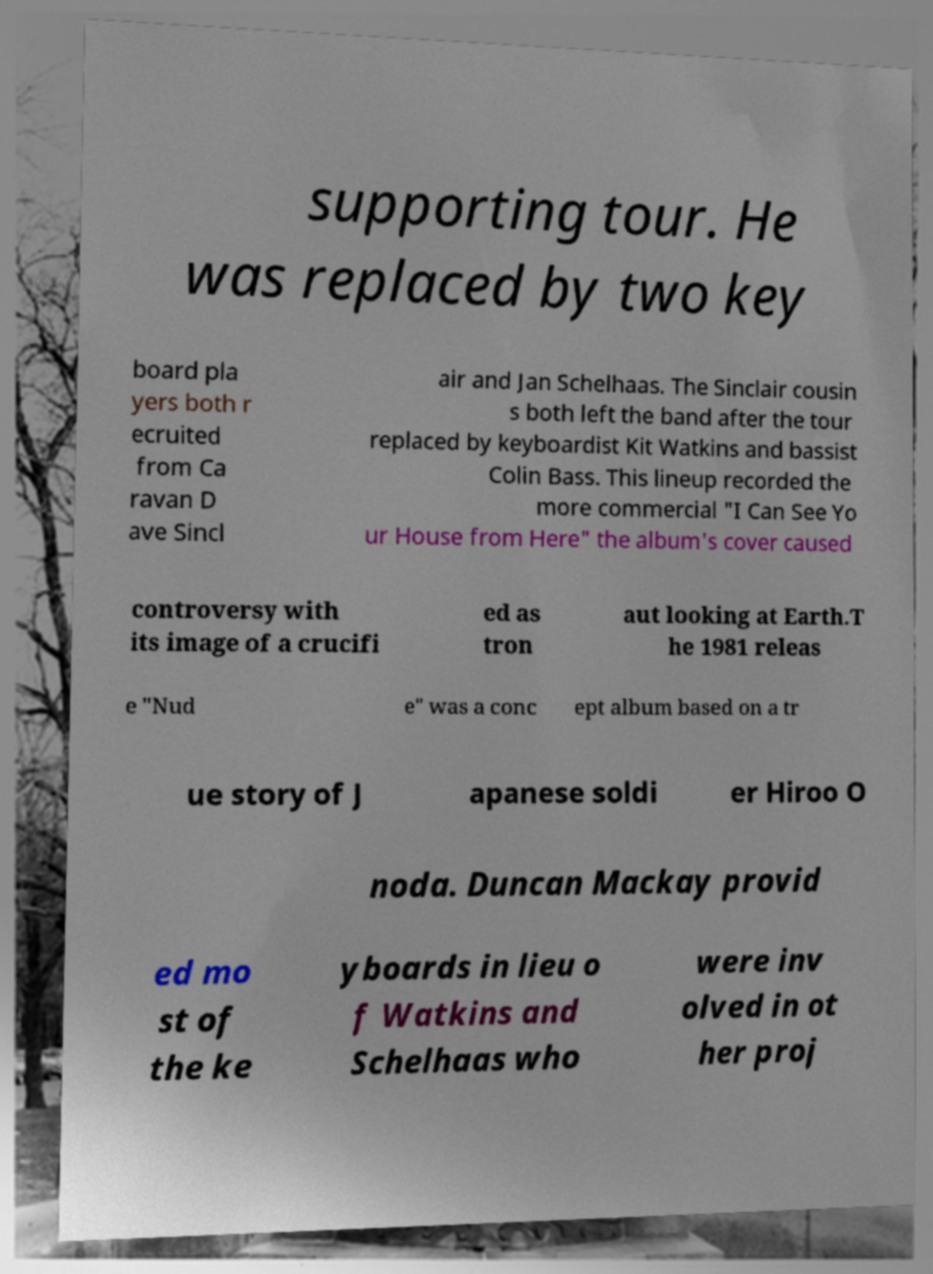What messages or text are displayed in this image? I need them in a readable, typed format. supporting tour. He was replaced by two key board pla yers both r ecruited from Ca ravan D ave Sincl air and Jan Schelhaas. The Sinclair cousin s both left the band after the tour replaced by keyboardist Kit Watkins and bassist Colin Bass. This lineup recorded the more commercial "I Can See Yo ur House from Here" the album's cover caused controversy with its image of a crucifi ed as tron aut looking at Earth.T he 1981 releas e "Nud e" was a conc ept album based on a tr ue story of J apanese soldi er Hiroo O noda. Duncan Mackay provid ed mo st of the ke yboards in lieu o f Watkins and Schelhaas who were inv olved in ot her proj 